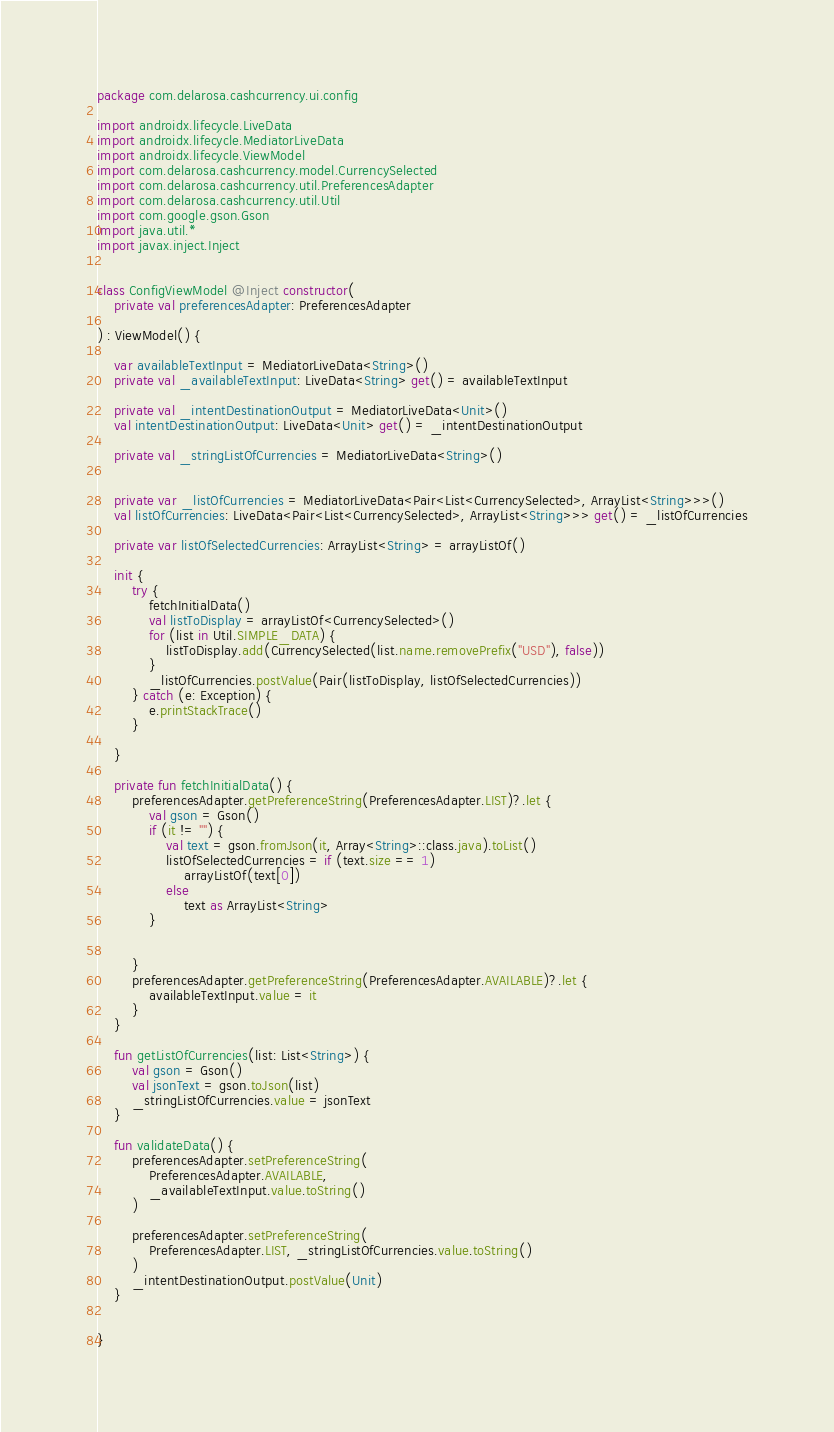Convert code to text. <code><loc_0><loc_0><loc_500><loc_500><_Kotlin_>package com.delarosa.cashcurrency.ui.config

import androidx.lifecycle.LiveData
import androidx.lifecycle.MediatorLiveData
import androidx.lifecycle.ViewModel
import com.delarosa.cashcurrency.model.CurrencySelected
import com.delarosa.cashcurrency.util.PreferencesAdapter
import com.delarosa.cashcurrency.util.Util
import com.google.gson.Gson
import java.util.*
import javax.inject.Inject


class ConfigViewModel @Inject constructor(
    private val preferencesAdapter: PreferencesAdapter

) : ViewModel() {

    var availableTextInput = MediatorLiveData<String>()
    private val _availableTextInput: LiveData<String> get() = availableTextInput

    private val _intentDestinationOutput = MediatorLiveData<Unit>()
    val intentDestinationOutput: LiveData<Unit> get() = _intentDestinationOutput

    private val _stringListOfCurrencies = MediatorLiveData<String>()


    private var _listOfCurrencies = MediatorLiveData<Pair<List<CurrencySelected>, ArrayList<String>>>()
    val listOfCurrencies: LiveData<Pair<List<CurrencySelected>, ArrayList<String>>> get() = _listOfCurrencies

    private var listOfSelectedCurrencies: ArrayList<String> = arrayListOf()

    init {
        try {
            fetchInitialData()
            val listToDisplay = arrayListOf<CurrencySelected>()
            for (list in Util.SIMPLE_DATA) {
                listToDisplay.add(CurrencySelected(list.name.removePrefix("USD"), false))
            }
            _listOfCurrencies.postValue(Pair(listToDisplay, listOfSelectedCurrencies))
        } catch (e: Exception) {
            e.printStackTrace()
        }

    }

    private fun fetchInitialData() {
        preferencesAdapter.getPreferenceString(PreferencesAdapter.LIST)?.let {
            val gson = Gson()
            if (it != "") {
                val text = gson.fromJson(it, Array<String>::class.java).toList()
                listOfSelectedCurrencies = if (text.size == 1)
                    arrayListOf(text[0])
                else
                    text as ArrayList<String>
            }


        }
        preferencesAdapter.getPreferenceString(PreferencesAdapter.AVAILABLE)?.let {
            availableTextInput.value = it
        }
    }

    fun getListOfCurrencies(list: List<String>) {
        val gson = Gson()
        val jsonText = gson.toJson(list)
        _stringListOfCurrencies.value = jsonText
    }

    fun validateData() {
        preferencesAdapter.setPreferenceString(
            PreferencesAdapter.AVAILABLE,
            _availableTextInput.value.toString()
        )

        preferencesAdapter.setPreferenceString(
            PreferencesAdapter.LIST, _stringListOfCurrencies.value.toString()
        )
        _intentDestinationOutput.postValue(Unit)
    }


}

</code> 